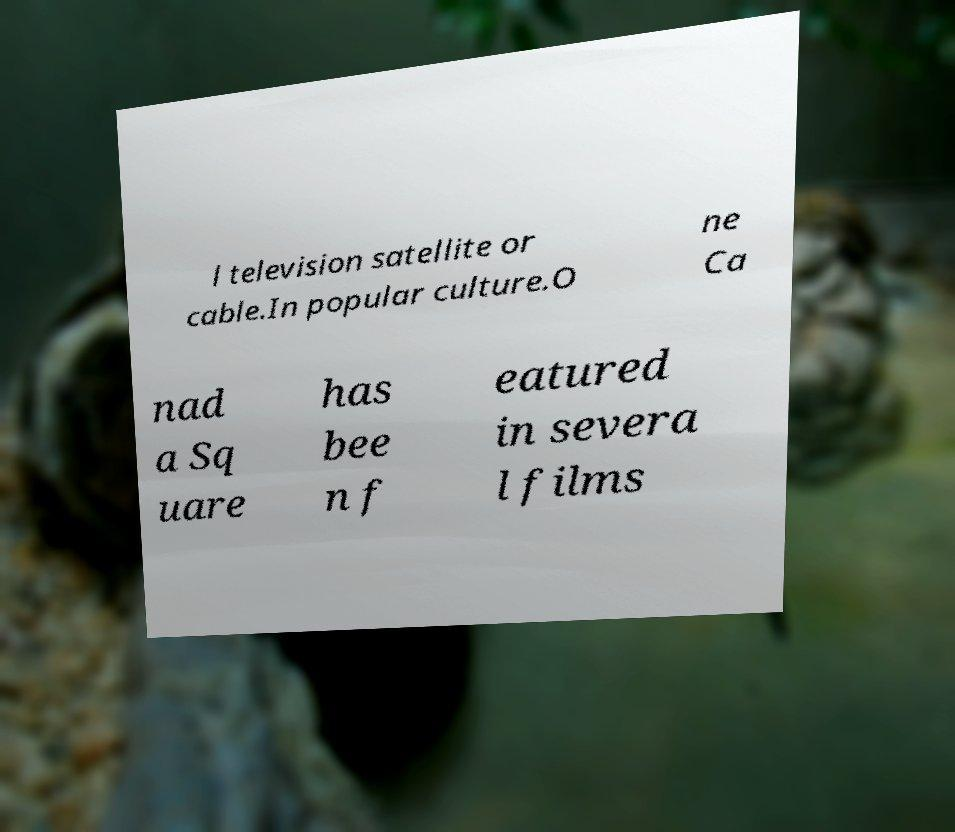What messages or text are displayed in this image? I need them in a readable, typed format. l television satellite or cable.In popular culture.O ne Ca nad a Sq uare has bee n f eatured in severa l films 